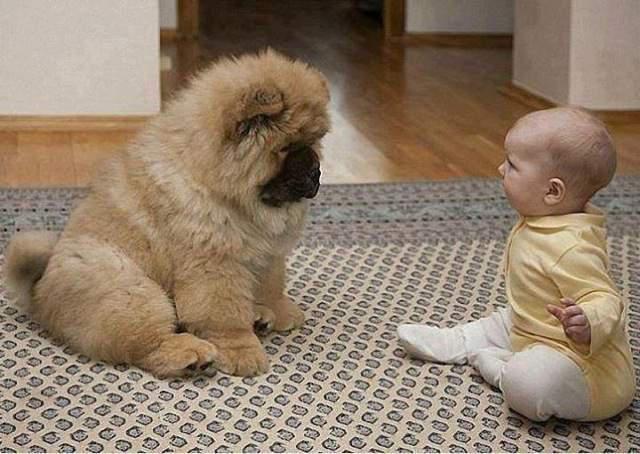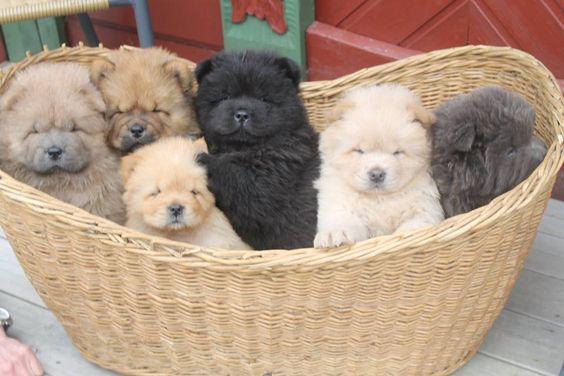The first image is the image on the left, the second image is the image on the right. Examine the images to the left and right. Is the description "An image shows at least one chow dog in a basket-like container." accurate? Answer yes or no. Yes. The first image is the image on the left, the second image is the image on the right. Given the left and right images, does the statement "There is at least one human in one of the images." hold true? Answer yes or no. Yes. The first image is the image on the left, the second image is the image on the right. Analyze the images presented: Is the assertion "There is one human head in the image on the left." valid? Answer yes or no. Yes. 